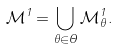Convert formula to latex. <formula><loc_0><loc_0><loc_500><loc_500>\mathcal { M } ^ { 1 } = \bigcup _ { \theta \in \Theta } \mathcal { M } _ { \theta } ^ { 1 } .</formula> 